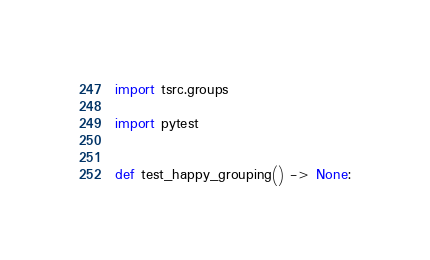Convert code to text. <code><loc_0><loc_0><loc_500><loc_500><_Python_>import tsrc.groups

import pytest


def test_happy_grouping() -> None:</code> 